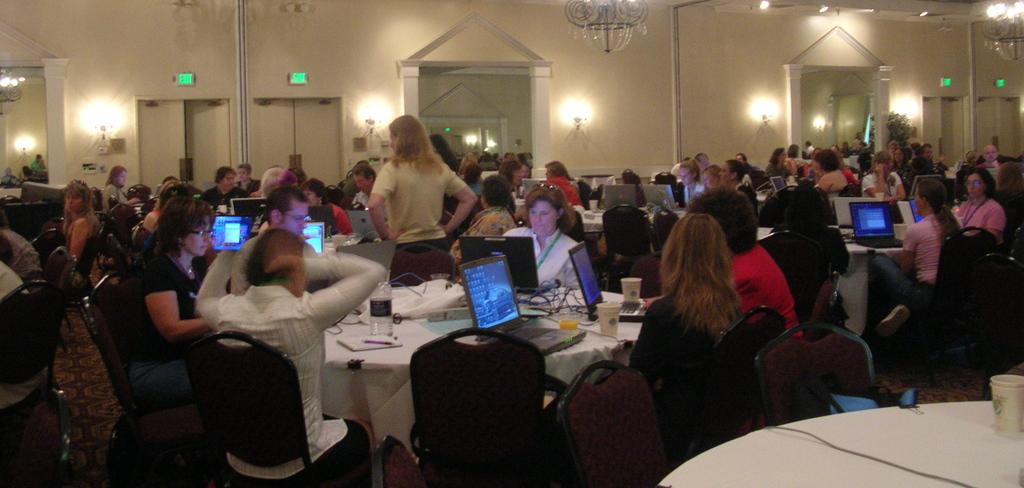What are the people in the image doing? There is a group of people sitting in chairs in the image. What is in front of the group of people? There is a table in front of the group of people. What is on the table? The table has laptops on it. Is there anyone standing among the seated people? Yes, there is a person standing in the center of the group. What type of guitar is the person playing in the image? There is no guitar present in the image; the person standing in the center is not playing any instrument. 